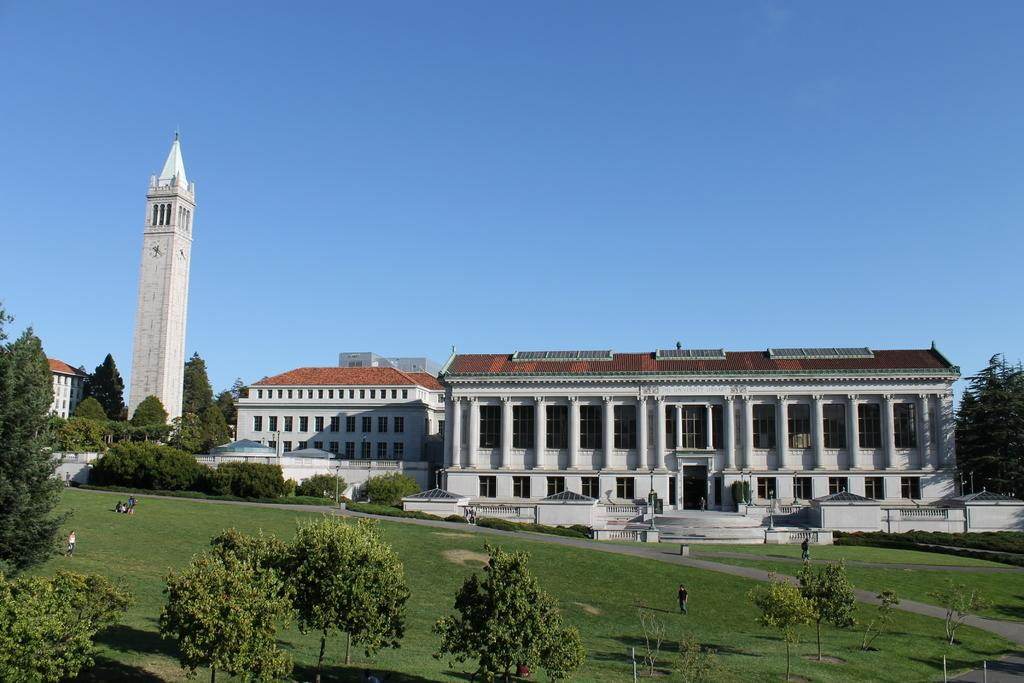What type of structures can be seen in the image? There are buildings in the image. What feature do the buildings have? The buildings have windows. What else can be seen in the image besides the buildings? There are poles, trees, and people in the image. What is visible in the background of the image? The sky is visible in the image. How many potatoes are being used by the society in the image? There is no reference to potatoes or a society in the image, so it is not possible to answer that question. 